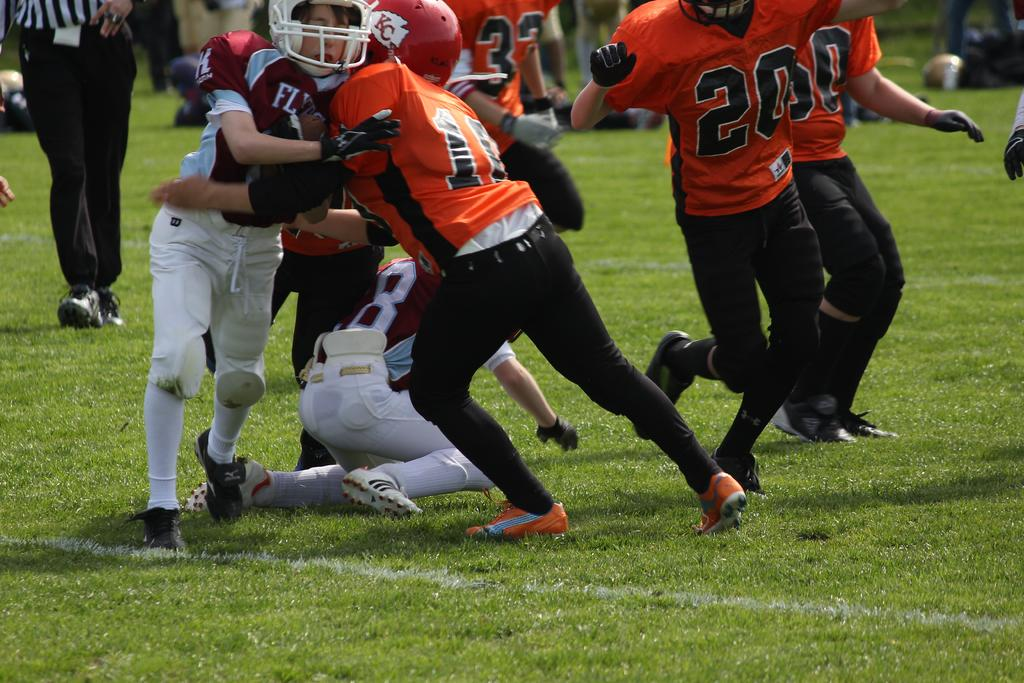How many people are in the image? There is a group of people in the image, but the exact number is not specified. What is the position of the people in the image? The people are on the ground in the image. What type of surface can be seen beneath the people? There is grass visible in the image. What type of lamp is illuminating the vegetable garden in the image? There is no lamp or vegetable garden present in the image. 